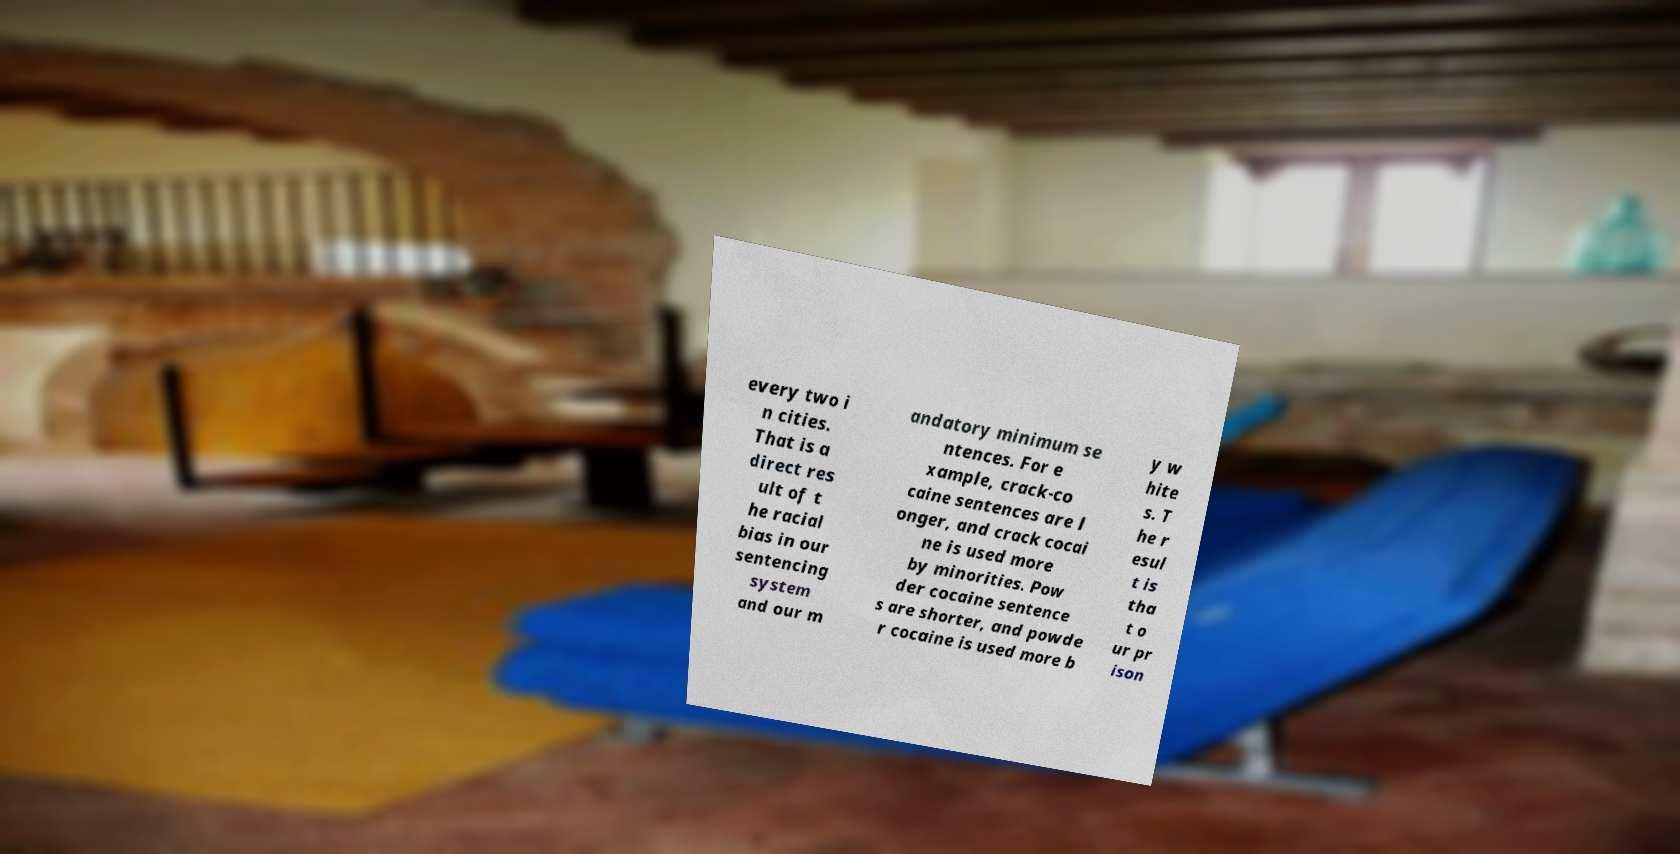Could you extract and type out the text from this image? every two i n cities. That is a direct res ult of t he racial bias in our sentencing system and our m andatory minimum se ntences. For e xample, crack-co caine sentences are l onger, and crack cocai ne is used more by minorities. Pow der cocaine sentence s are shorter, and powde r cocaine is used more b y w hite s. T he r esul t is tha t o ur pr ison 